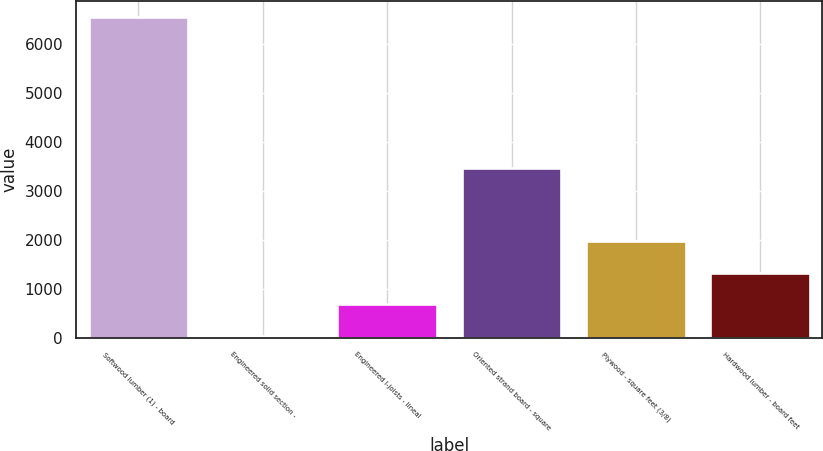<chart> <loc_0><loc_0><loc_500><loc_500><bar_chart><fcel>Softwood lumber (1) - board<fcel>Engineered solid section -<fcel>Engineered I-joists - lineal<fcel>Oriented strand board - square<fcel>Plywood - square feet (3/8)<fcel>Hardwood lumber - board feet<nl><fcel>6538<fcel>30<fcel>680.8<fcel>3466<fcel>1982.4<fcel>1331.6<nl></chart> 